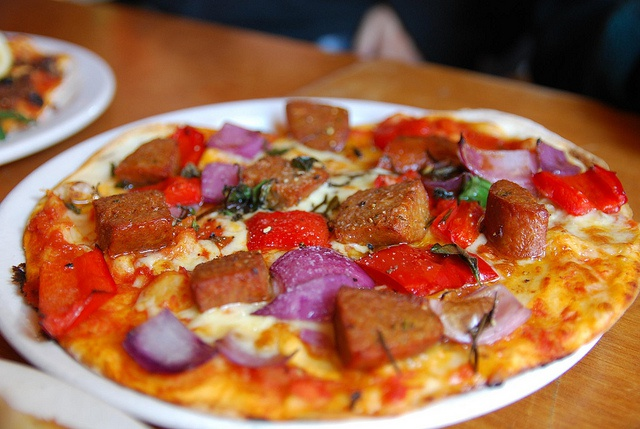Describe the objects in this image and their specific colors. I can see dining table in brown, maroon, lightgray, and red tones, pizza in maroon, brown, red, and orange tones, and pizza in maroon, brown, olive, and gray tones in this image. 